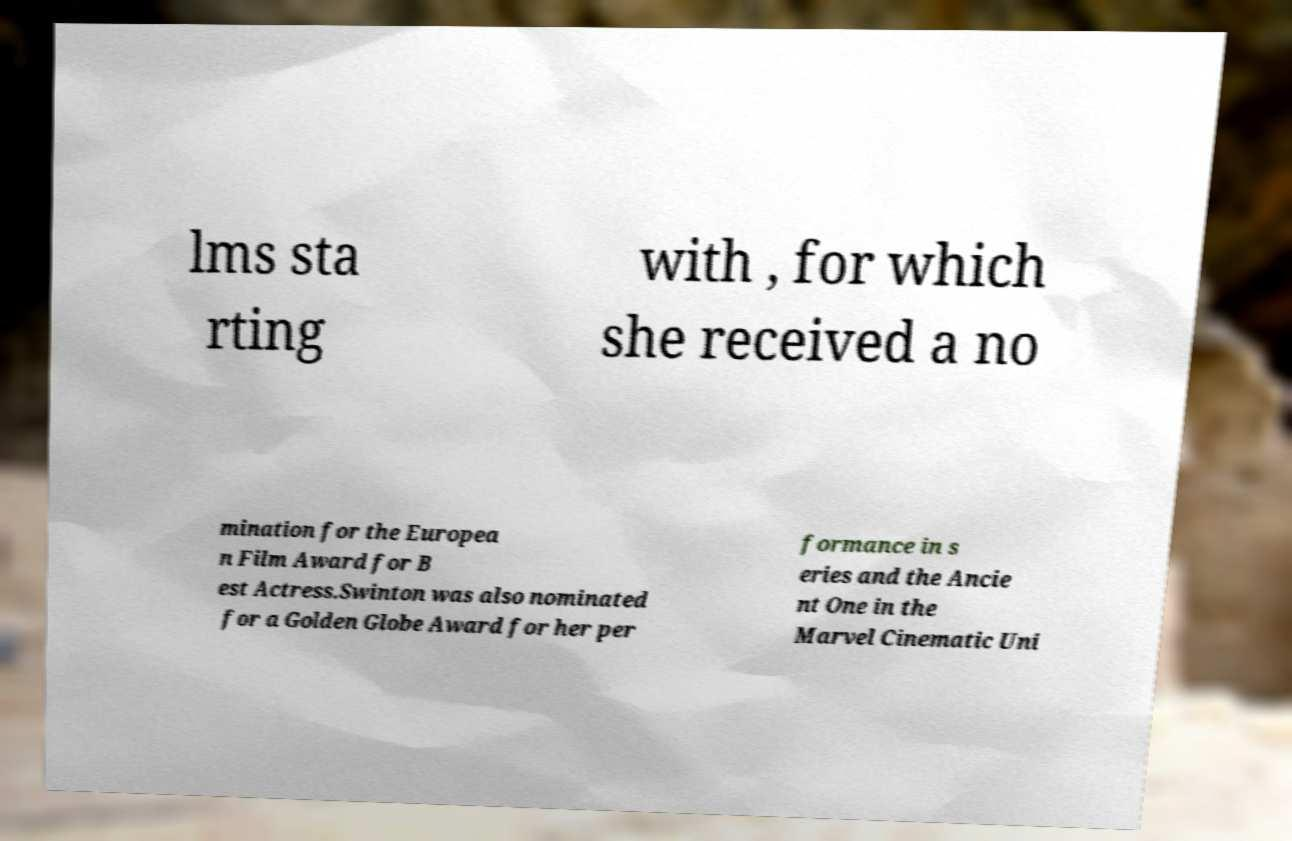There's text embedded in this image that I need extracted. Can you transcribe it verbatim? lms sta rting with , for which she received a no mination for the Europea n Film Award for B est Actress.Swinton was also nominated for a Golden Globe Award for her per formance in s eries and the Ancie nt One in the Marvel Cinematic Uni 